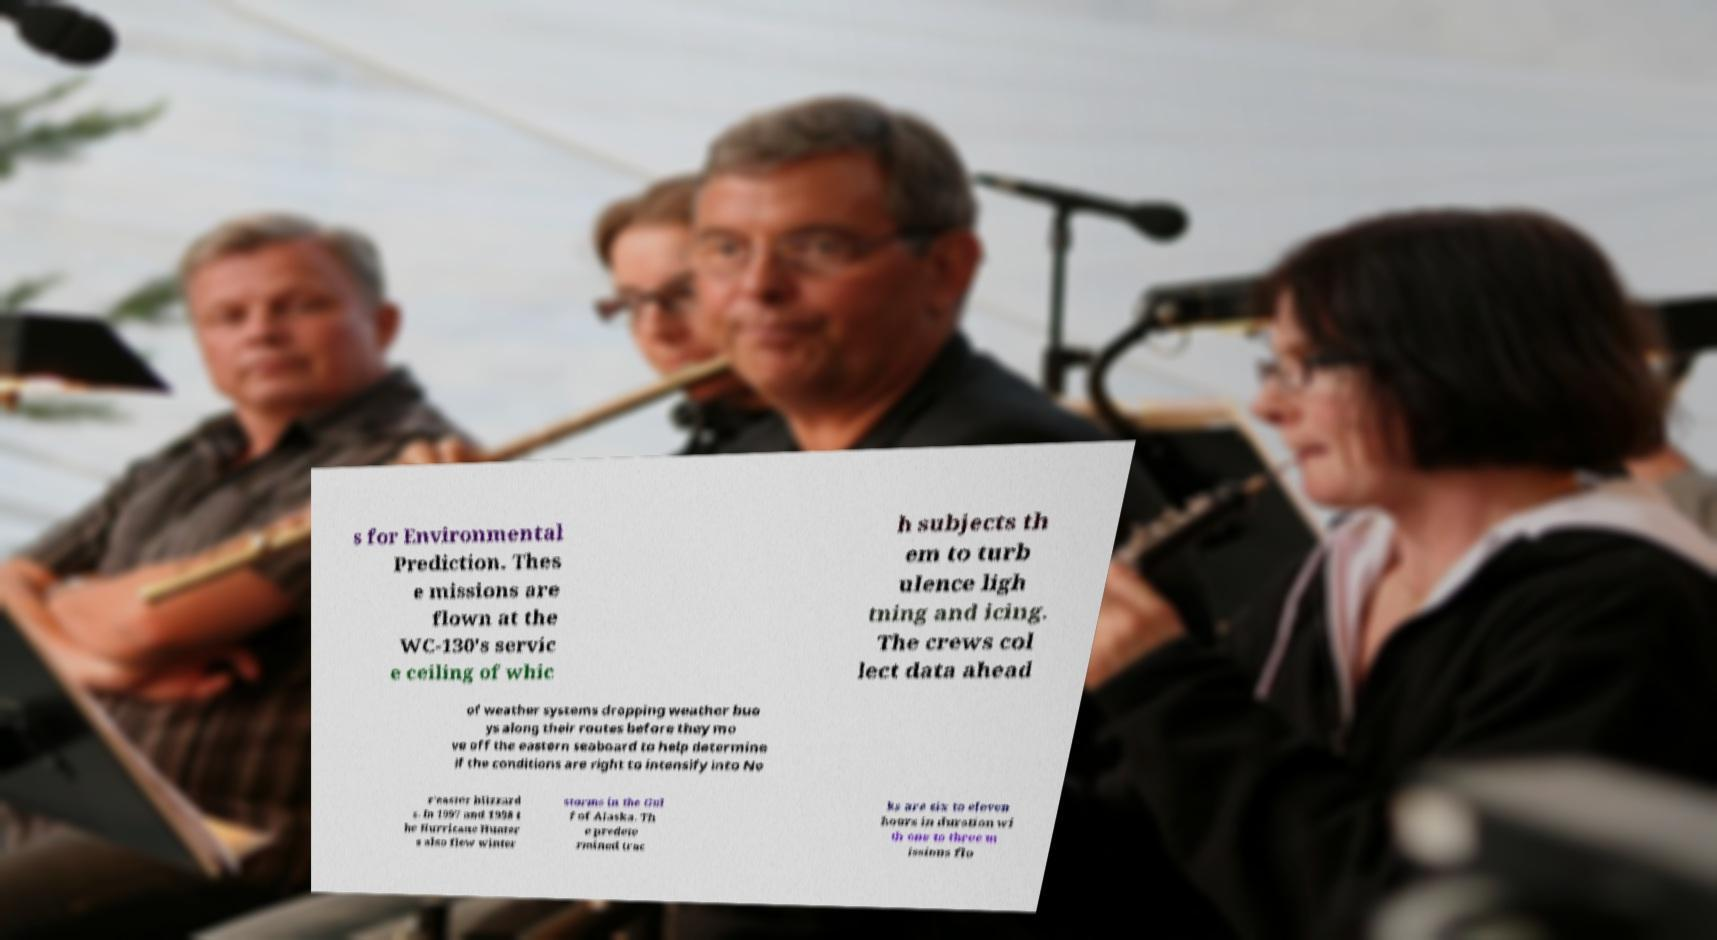For documentation purposes, I need the text within this image transcribed. Could you provide that? s for Environmental Prediction. Thes e missions are flown at the WC-130's servic e ceiling of whic h subjects th em to turb ulence ligh tning and icing. The crews col lect data ahead of weather systems dropping weather buo ys along their routes before they mo ve off the eastern seaboard to help determine if the conditions are right to intensify into No r'easter blizzard s. In 1997 and 1998 t he Hurricane Hunter s also flew winter storms in the Gul f of Alaska. Th e predete rmined trac ks are six to eleven hours in duration wi th one to three m issions flo 